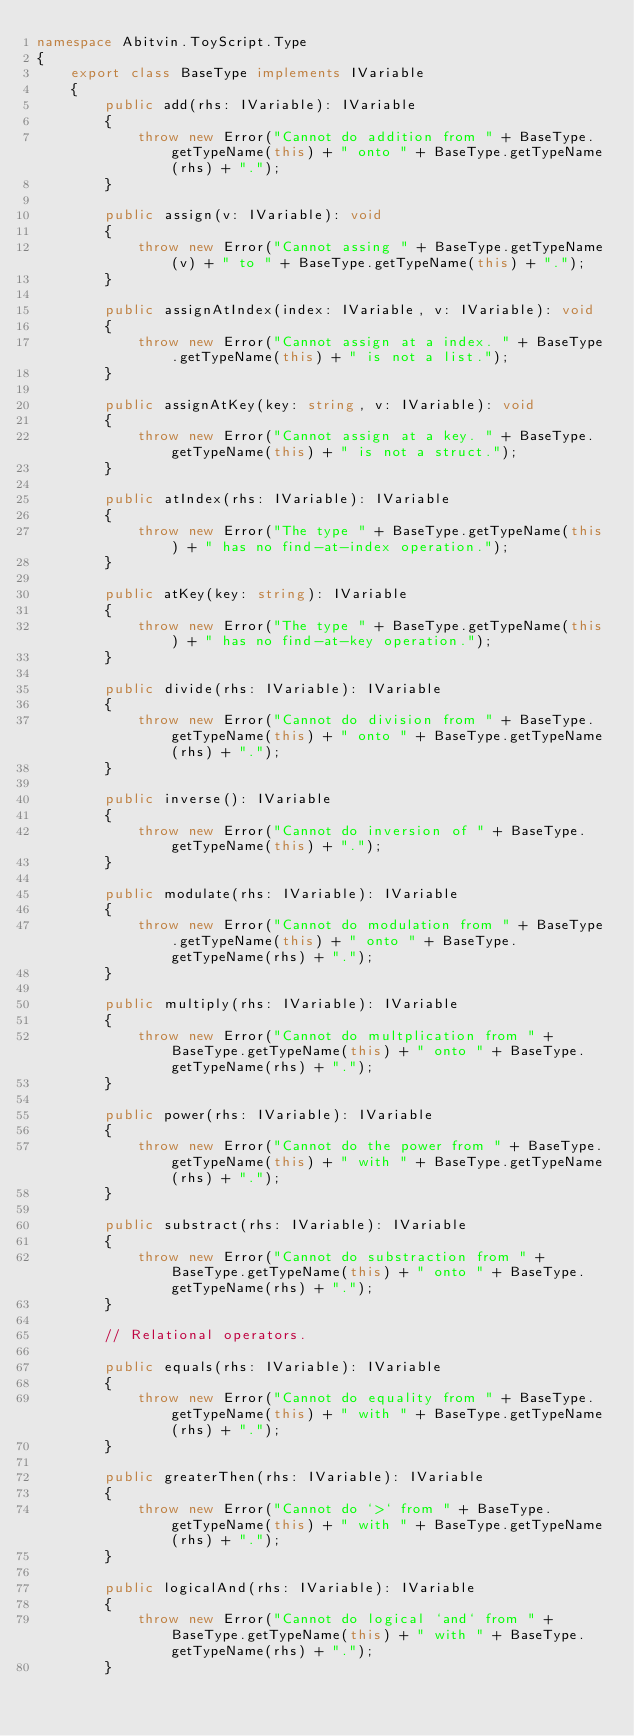<code> <loc_0><loc_0><loc_500><loc_500><_TypeScript_>namespace Abitvin.ToyScript.Type
{
	export class BaseType implements IVariable
	{
		public add(rhs: IVariable): IVariable
		{
			throw new Error("Cannot do addition from " + BaseType.getTypeName(this) + " onto " + BaseType.getTypeName(rhs) + ".");
		}

        public assign(v: IVariable): void
        {
            throw new Error("Cannot assing " + BaseType.getTypeName(v) + " to " + BaseType.getTypeName(this) + ".");
        }

		public assignAtIndex(index: IVariable, v: IVariable): void
        {
            throw new Error("Cannot assign at a index. " + BaseType.getTypeName(this) + " is not a list.");
        }

		public assignAtKey(key: string, v: IVariable): void
        {
            throw new Error("Cannot assign at a key. " + BaseType.getTypeName(this) + " is not a struct.");
        }

		public atIndex(rhs: IVariable): IVariable
        {
            throw new Error("The type " + BaseType.getTypeName(this) + " has no find-at-index operation.");
        }

		public atKey(key: string): IVariable
        {
            throw new Error("The type " + BaseType.getTypeName(this) + " has no find-at-key operation.");
        }

		public divide(rhs: IVariable): IVariable
		{
			throw new Error("Cannot do division from " + BaseType.getTypeName(this) + " onto " + BaseType.getTypeName(rhs) + ".");
		}

		public inverse(): IVariable
		{
			throw new Error("Cannot do inversion of " + BaseType.getTypeName(this) + ".");
		}

		public modulate(rhs: IVariable): IVariable
		{
			throw new Error("Cannot do modulation from " + BaseType.getTypeName(this) + " onto " + BaseType.getTypeName(rhs) + ".");
		}

		public multiply(rhs: IVariable): IVariable
		{
			throw new Error("Cannot do multplication from " + BaseType.getTypeName(this) + " onto " + BaseType.getTypeName(rhs) + ".");
		}

		public power(rhs: IVariable): IVariable
		{
			throw new Error("Cannot do the power from " + BaseType.getTypeName(this) + " with " + BaseType.getTypeName(rhs) + ".");
		}

		public substract(rhs: IVariable): IVariable
		{
			throw new Error("Cannot do substraction from " + BaseType.getTypeName(this) + " onto " + BaseType.getTypeName(rhs) + ".");
		}

		// Relational operators.

		public equals(rhs: IVariable): IVariable
		{
			throw new Error("Cannot do equality from " + BaseType.getTypeName(this) + " with " + BaseType.getTypeName(rhs) + ".");
		}

		public greaterThen(rhs: IVariable): IVariable
		{
			throw new Error("Cannot do `>` from " + BaseType.getTypeName(this) + " with " + BaseType.getTypeName(rhs) + ".");
		}

		public logicalAnd(rhs: IVariable): IVariable
		{
			throw new Error("Cannot do logical `and` from " + BaseType.getTypeName(this) + " with " + BaseType.getTypeName(rhs) + ".");
		}
</code> 